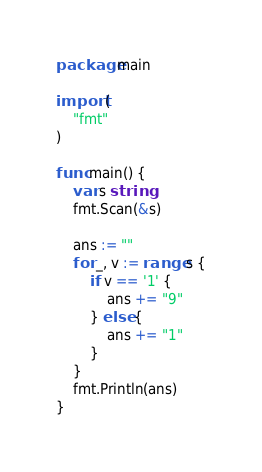Convert code to text. <code><loc_0><loc_0><loc_500><loc_500><_Go_>package main

import (
	"fmt"
)

func main() {
	var s string
	fmt.Scan(&s)

	ans := ""
	for _, v := range s {
		if v == '1' {
			ans += "9"
		} else {
			ans += "1"
		}
	}
	fmt.Println(ans)
}
</code> 